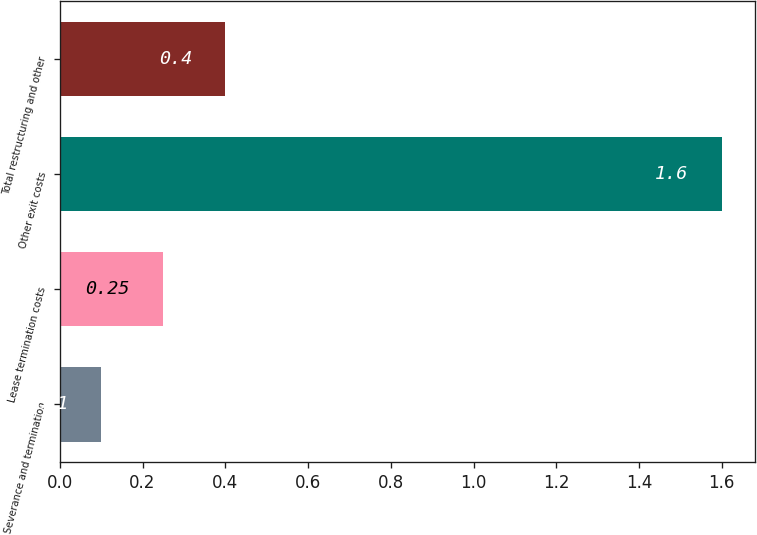<chart> <loc_0><loc_0><loc_500><loc_500><bar_chart><fcel>Severance and termination<fcel>Lease termination costs<fcel>Other exit costs<fcel>Total restructuring and other<nl><fcel>0.1<fcel>0.25<fcel>1.6<fcel>0.4<nl></chart> 